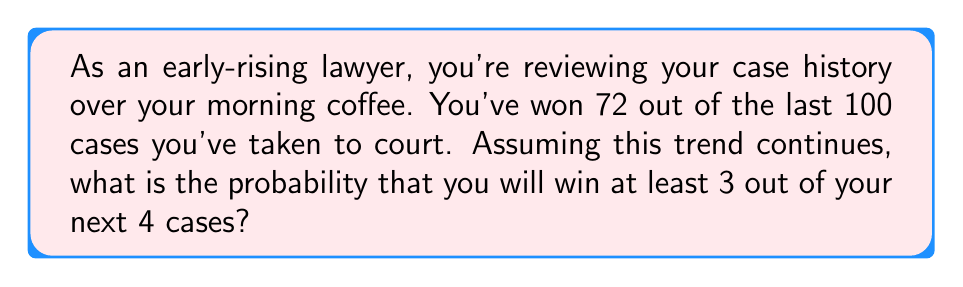Give your solution to this math problem. Let's approach this step-by-step:

1) First, we need to identify the probability of winning a single case. Based on the historical data:

   $P(\text{win}) = \frac{72}{100} = 0.72$

2) This scenario follows a binomial distribution, where we want at least 3 successes out of 4 trials.

3) The probability of winning at least 3 out of 4 cases is the sum of the probabilities of winning 3 cases and winning all 4 cases.

4) Let's calculate these probabilities using the binomial probability formula:

   $P(X = k) = \binom{n}{k} p^k (1-p)^{n-k}$

   Where $n = 4$, $p = 0.72$, and $k = 3$ or $4$

5) For winning exactly 3 cases:

   $P(X = 3) = \binom{4}{3} (0.72)^3 (1-0.72)^{4-3}$
              $= 4 \times 0.72^3 \times 0.28$
              $= 4 \times 0.373248 \times 0.28$
              $= 0.417638$

6) For winning all 4 cases:

   $P(X = 4) = \binom{4}{4} (0.72)^4 (1-0.72)^{4-4}$
              $= 1 \times 0.72^4 \times 1$
              $= 0.269042$

7) The probability of winning at least 3 cases is the sum of these probabilities:

   $P(X \geq 3) = P(X = 3) + P(X = 4)$
                $= 0.417638 + 0.269042$
                $= 0.686680$

Therefore, the probability of winning at least 3 out of the next 4 cases is approximately 0.686680 or 68.67%.
Answer: $0.6867$ or $68.67\%$ 